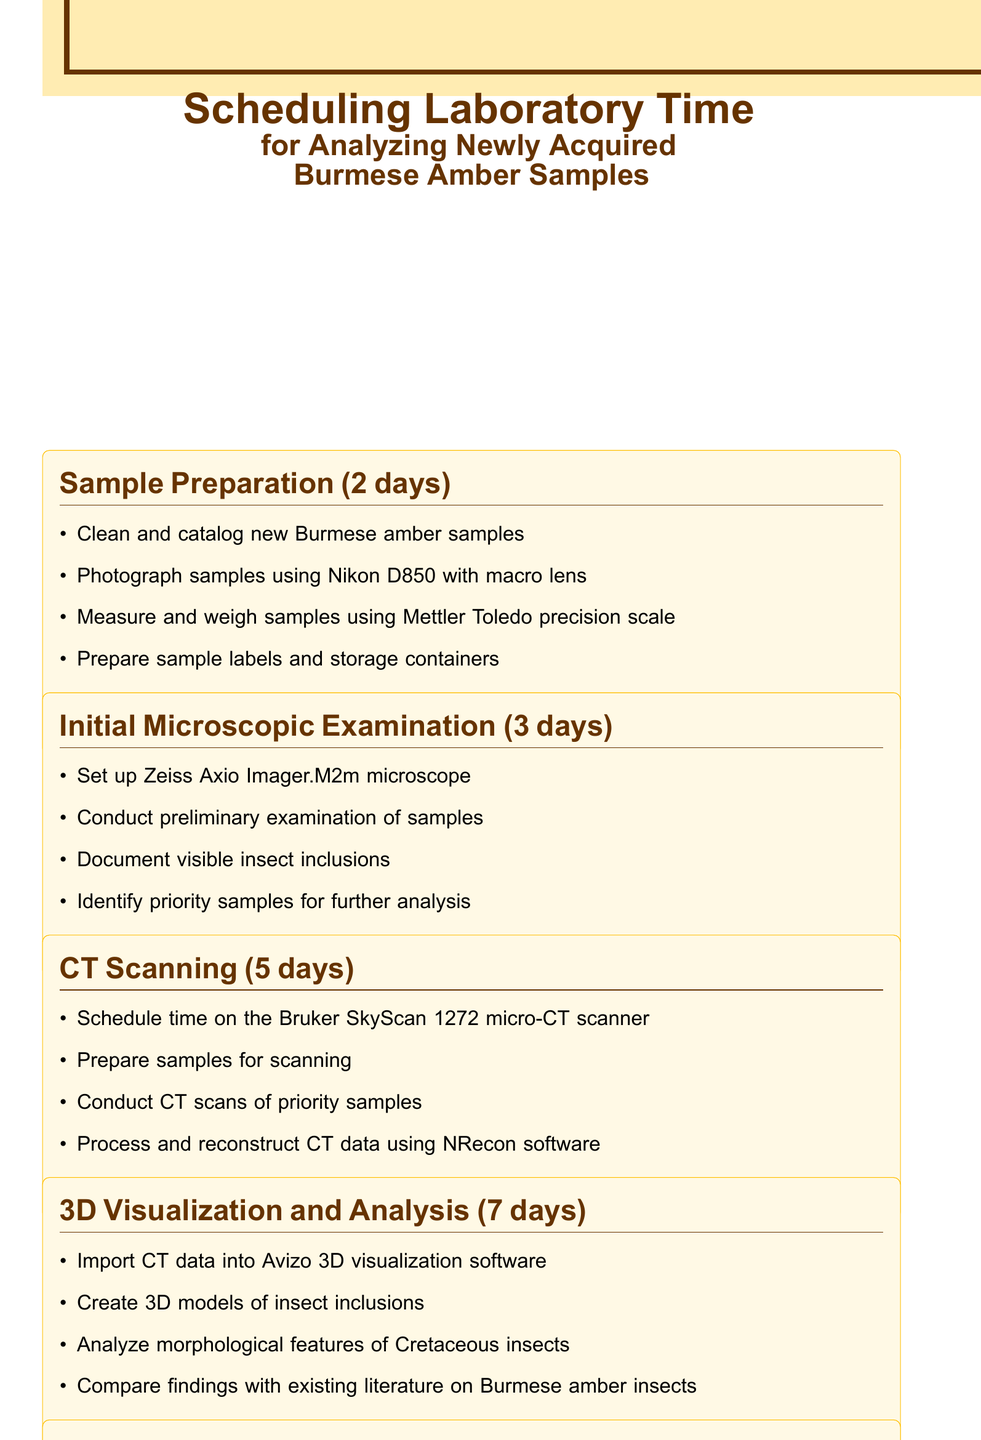What is the total duration for sample preparation? The total duration for sample preparation is specified in the document as 2 days.
Answer: 2 days What equipment is required for CT scanning? The equipment needed for CT scanning is listed in the document.
Answer: Bruker SkyScan 1272 micro-CT scanner, Workstation with NRecon software How many days are allocated for 3D visualization and analysis? The number of days allocated for this task is mentioned in the document.
Answer: 7 days Which microscope needs to be set up for the initial microscopic examination? The specific microscope mentioned for this examination is indicated in the document.
Answer: Zeiss Axio Imager.M2m microscope What are the first tasks listed under sample preparation? The first tasks included in the sample preparation section are outlined in the document.
Answer: Clean and catalog new Burmese amber samples How many total days are spent on synchrotron radiation analysis? The total duration for synchrotron radiation analysis can be found within the document.
Answer: 4 days Which software is used for data reconstruction in CT scanning? The specific software for processing and reconstructing CT data is stated in the document.
Answer: NRecon software What will be prepared during the data compilation and preliminary report phase? The tasks related to data preparation in this phase are listed in the document.
Answer: Compile preliminary findings on Cretaceous insect specimens What is recommended for further consultation? The recommendation for consultation is provided in the additional notes of the document.
Answer: Dr. David Grimaldi 